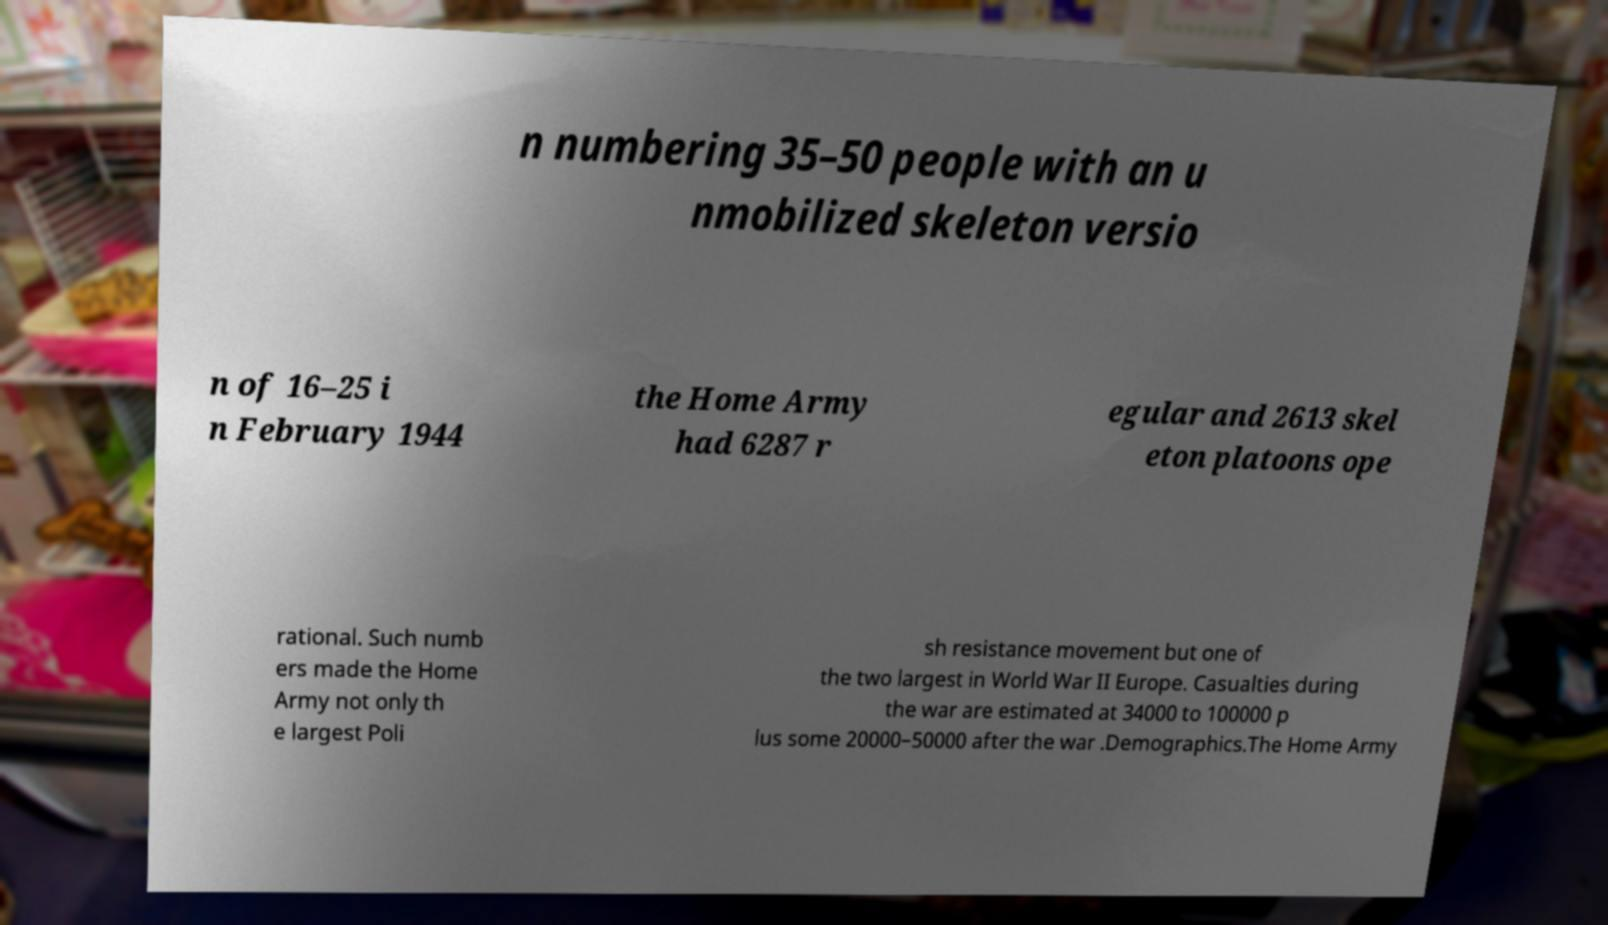Can you accurately transcribe the text from the provided image for me? n numbering 35–50 people with an u nmobilized skeleton versio n of 16–25 i n February 1944 the Home Army had 6287 r egular and 2613 skel eton platoons ope rational. Such numb ers made the Home Army not only th e largest Poli sh resistance movement but one of the two largest in World War II Europe. Casualties during the war are estimated at 34000 to 100000 p lus some 20000–50000 after the war .Demographics.The Home Army 